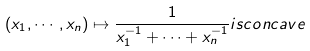Convert formula to latex. <formula><loc_0><loc_0><loc_500><loc_500>( x _ { 1 } , \cdots , x _ { n } ) \mapsto \frac { 1 } { x _ { 1 } ^ { - 1 } + \cdots + x _ { n } ^ { - 1 } } i s c o n c a v e</formula> 